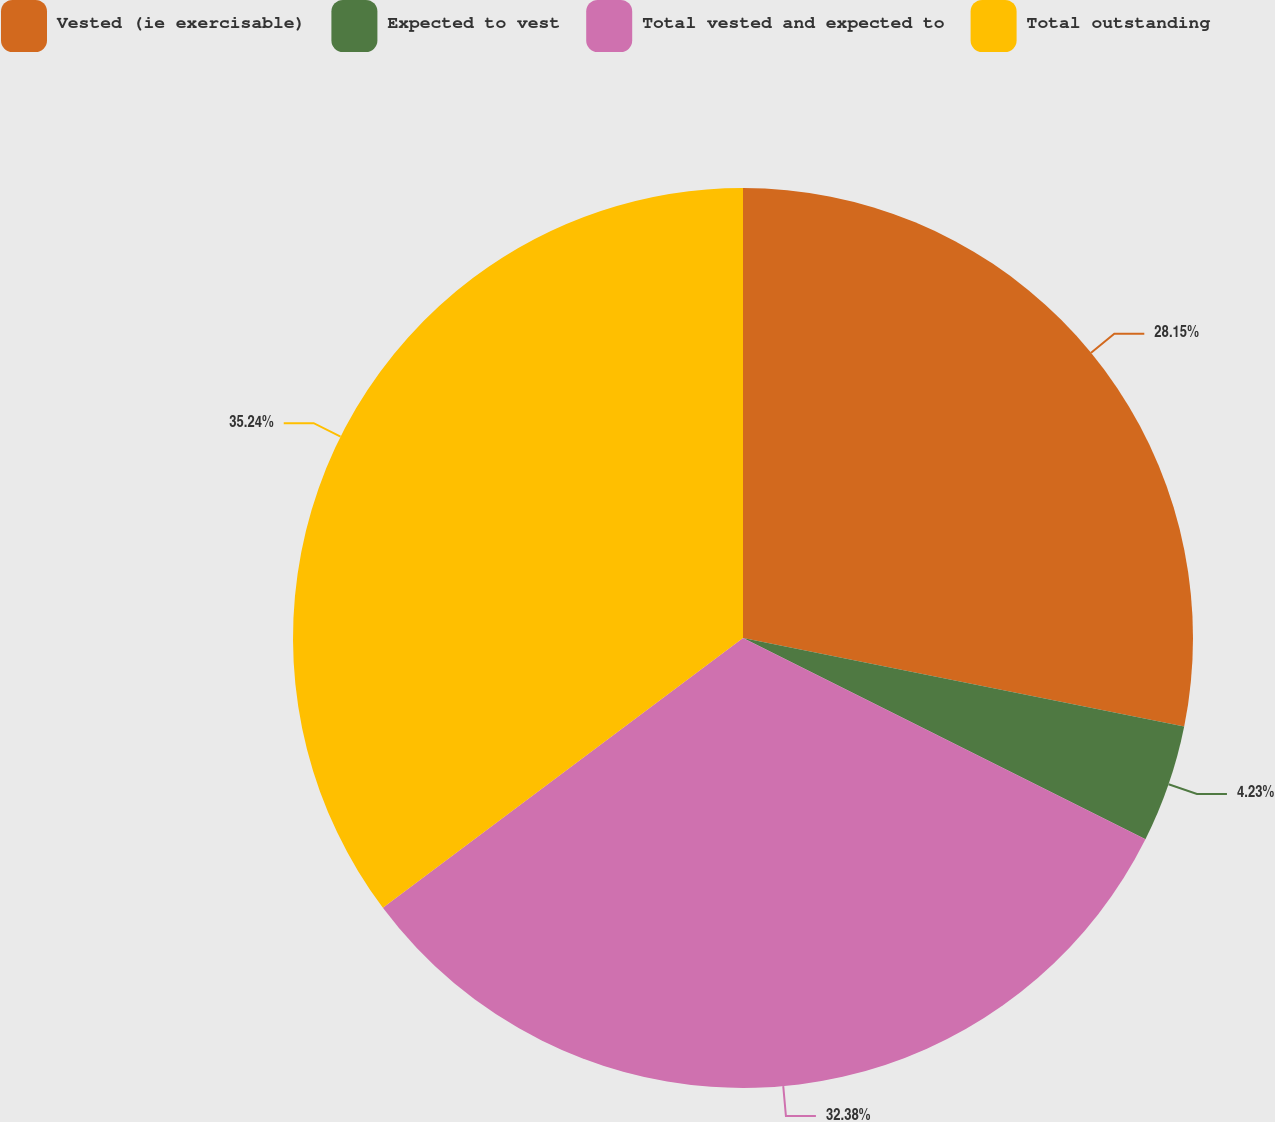Convert chart. <chart><loc_0><loc_0><loc_500><loc_500><pie_chart><fcel>Vested (ie exercisable)<fcel>Expected to vest<fcel>Total vested and expected to<fcel>Total outstanding<nl><fcel>28.15%<fcel>4.23%<fcel>32.38%<fcel>35.23%<nl></chart> 